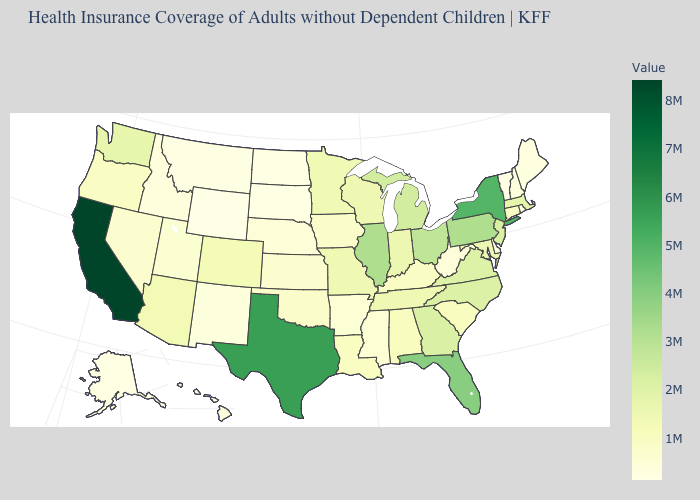Is the legend a continuous bar?
Be succinct. Yes. Which states have the highest value in the USA?
Short answer required. California. Does the map have missing data?
Answer briefly. No. Among the states that border Wyoming , does Utah have the highest value?
Answer briefly. No. 